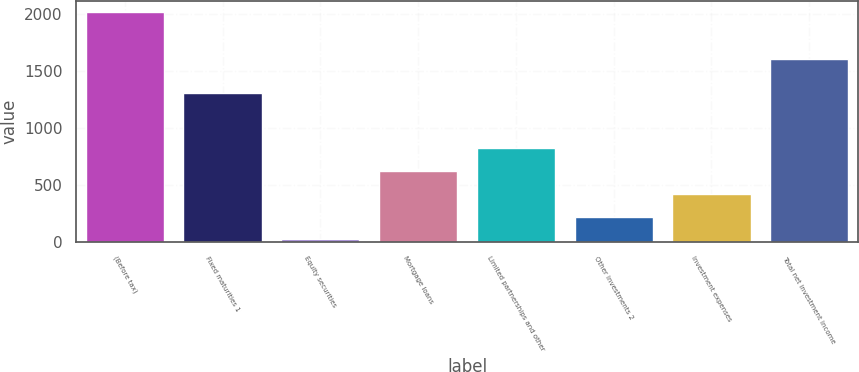Convert chart to OTSL. <chart><loc_0><loc_0><loc_500><loc_500><bar_chart><fcel>(Before tax)<fcel>Fixed maturities 1<fcel>Equity securities<fcel>Mortgage loans<fcel>Limited partnerships and other<fcel>Other investments 2<fcel>Investment expenses<fcel>Total net investment income<nl><fcel>2017<fcel>1303<fcel>24<fcel>621.9<fcel>821.2<fcel>223.3<fcel>422.6<fcel>1603<nl></chart> 